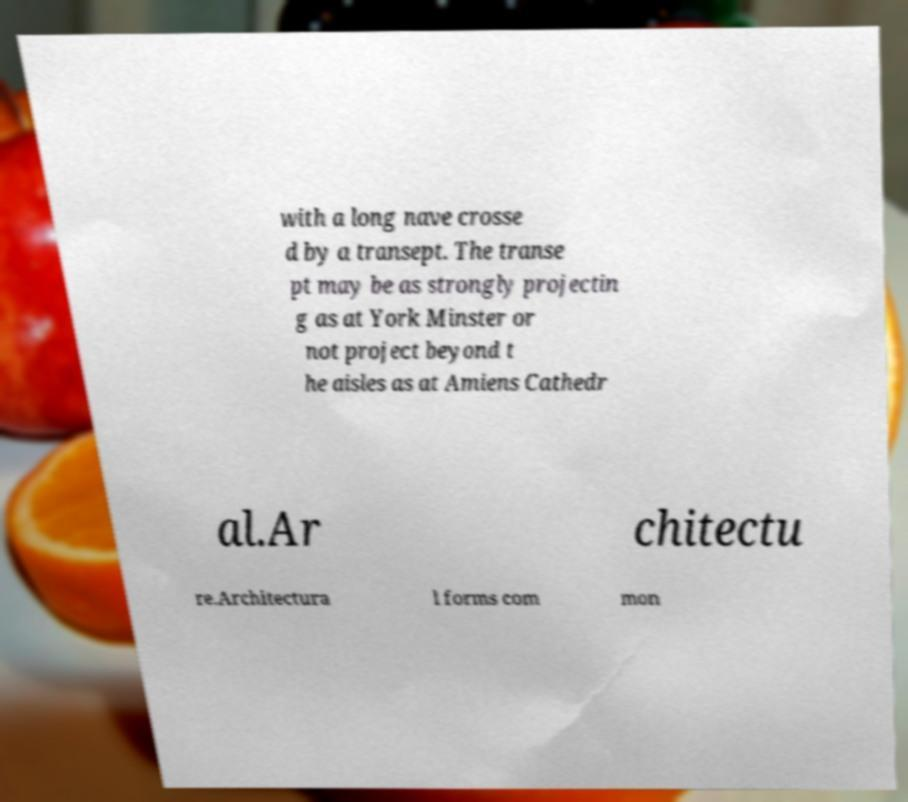For documentation purposes, I need the text within this image transcribed. Could you provide that? with a long nave crosse d by a transept. The transe pt may be as strongly projectin g as at York Minster or not project beyond t he aisles as at Amiens Cathedr al.Ar chitectu re.Architectura l forms com mon 